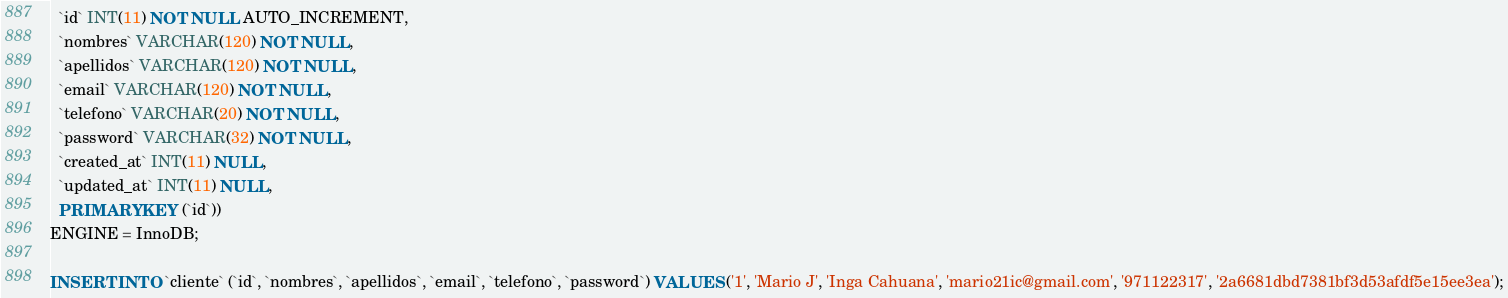<code> <loc_0><loc_0><loc_500><loc_500><_SQL_>  `id` INT(11) NOT NULL AUTO_INCREMENT,
  `nombres` VARCHAR(120) NOT NULL,
  `apellidos` VARCHAR(120) NOT NULL,
  `email` VARCHAR(120) NOT NULL,
  `telefono` VARCHAR(20) NOT NULL,
  `password` VARCHAR(32) NOT NULL,
  `created_at` INT(11) NULL,
  `updated_at` INT(11) NULL,
  PRIMARY KEY (`id`))
ENGINE = InnoDB;

INSERT INTO `cliente` (`id`, `nombres`, `apellidos`, `email`, `telefono`, `password`) VALUES ('1', 'Mario J', 'Inga Cahuana', 'mario21ic@gmail.com', '971122317', '2a6681dbd7381bf3d53afdf5e15ee3ea');

</code> 